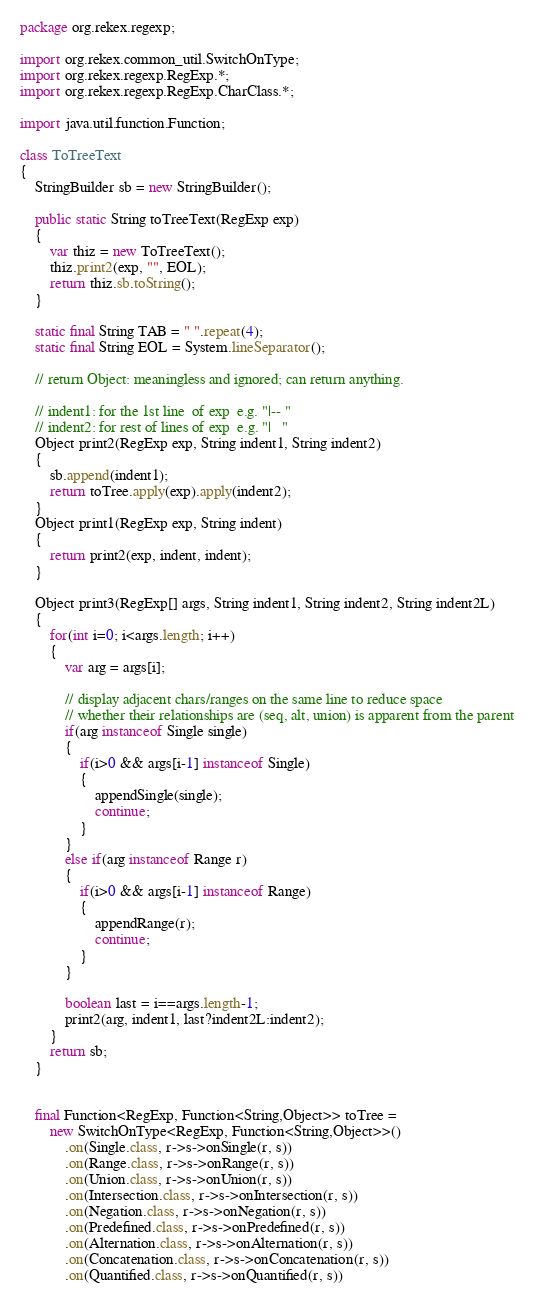<code> <loc_0><loc_0><loc_500><loc_500><_Java_>package org.rekex.regexp;

import org.rekex.common_util.SwitchOnType;
import org.rekex.regexp.RegExp.*;
import org.rekex.regexp.RegExp.CharClass.*;

import java.util.function.Function;

class ToTreeText
{
    StringBuilder sb = new StringBuilder();

    public static String toTreeText(RegExp exp)
    {
        var thiz = new ToTreeText();
        thiz.print2(exp, "", EOL);
        return thiz.sb.toString();
    }

    static final String TAB = " ".repeat(4);
    static final String EOL = System.lineSeparator();

    // return Object: meaningless and ignored; can return anything.

    // indent1: for the 1st line  of exp  e.g. "|-- "
    // indent2: for rest of lines of exp  e.g. "|   "
    Object print2(RegExp exp, String indent1, String indent2)
    {
        sb.append(indent1);
        return toTree.apply(exp).apply(indent2);
    }
    Object print1(RegExp exp, String indent)
    {
        return print2(exp, indent, indent);
    }

    Object print3(RegExp[] args, String indent1, String indent2, String indent2L)
    {
        for(int i=0; i<args.length; i++)
        {
            var arg = args[i];

            // display adjacent chars/ranges on the same line to reduce space
            // whether their relationships are (seq, alt, union) is apparent from the parent
            if(arg instanceof Single single)
            {
                if(i>0 && args[i-1] instanceof Single)
                {
                    appendSingle(single);
                    continue;
                }
            }
            else if(arg instanceof Range r)
            {
                if(i>0 && args[i-1] instanceof Range)
                {
                    appendRange(r);
                    continue;
                }
            }

            boolean last = i==args.length-1;
            print2(arg, indent1, last?indent2L:indent2);
        }
        return sb;
    }


    final Function<RegExp, Function<String,Object>> toTree =
        new SwitchOnType<RegExp, Function<String,Object>>()
            .on(Single.class, r->s->onSingle(r, s))
            .on(Range.class, r->s->onRange(r, s))
            .on(Union.class, r->s->onUnion(r, s))
            .on(Intersection.class, r->s->onIntersection(r, s))
            .on(Negation.class, r->s->onNegation(r, s))
            .on(Predefined.class, r->s->onPredefined(r, s))
            .on(Alternation.class, r->s->onAlternation(r, s))
            .on(Concatenation.class, r->s->onConcatenation(r, s))
            .on(Quantified.class, r->s->onQuantified(r, s))</code> 